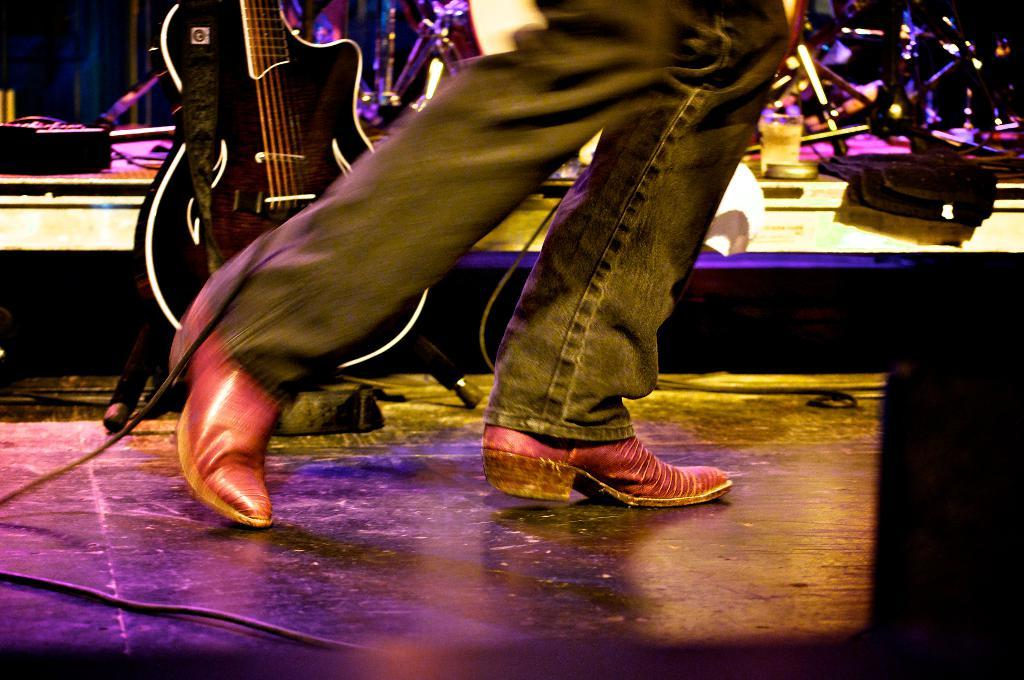What is present in the image? There is a man and a guitar in the image. Can you describe the man in the image? The facts provided do not give any specific details about the man's appearance or clothing. What is the man holding in the image? The man is holding a guitar in the image. What type of prison can be seen in the background of the image? There is no prison present in the image; it only features a man and a guitar. How many crates are visible in the image? There are no crates present in the image. 